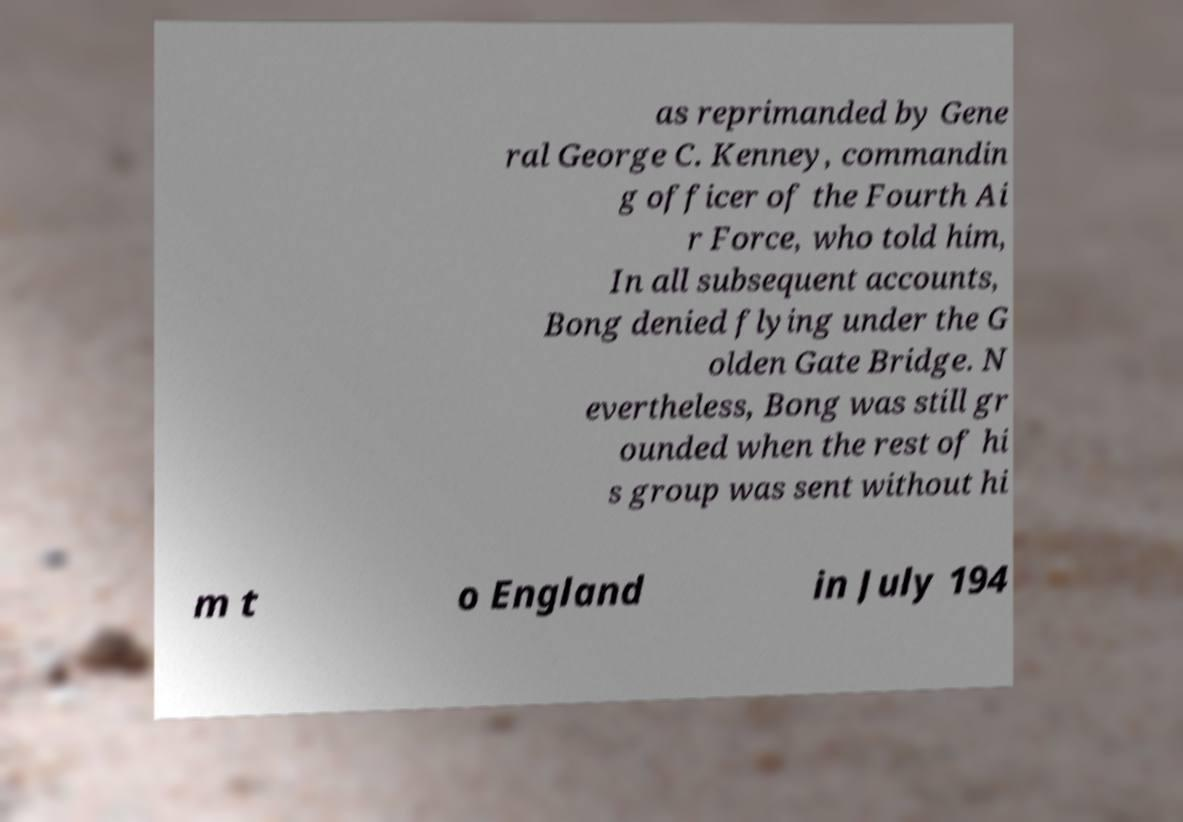Could you extract and type out the text from this image? as reprimanded by Gene ral George C. Kenney, commandin g officer of the Fourth Ai r Force, who told him, In all subsequent accounts, Bong denied flying under the G olden Gate Bridge. N evertheless, Bong was still gr ounded when the rest of hi s group was sent without hi m t o England in July 194 